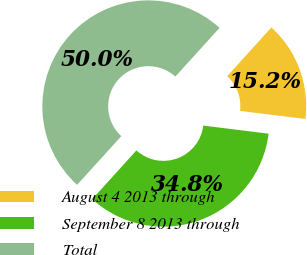Convert chart to OTSL. <chart><loc_0><loc_0><loc_500><loc_500><pie_chart><fcel>August 4 2013 through<fcel>September 8 2013 through<fcel>Total<nl><fcel>15.23%<fcel>34.77%<fcel>50.0%<nl></chart> 